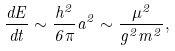Convert formula to latex. <formula><loc_0><loc_0><loc_500><loc_500>\frac { d E } { d t } \sim \frac { h ^ { 2 } } { 6 \pi } a ^ { 2 } \sim \frac { \mu ^ { 2 } } { g ^ { 2 } m ^ { 2 } } ,</formula> 